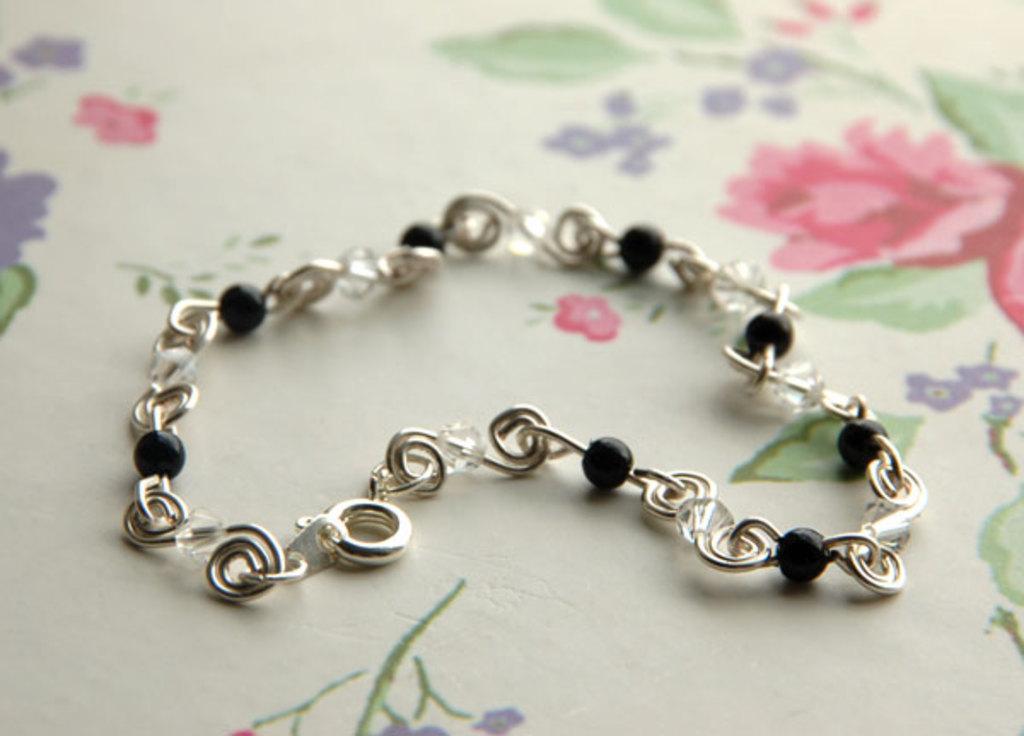How would you summarize this image in a sentence or two? It is a stainless steel chain with black color balls. 